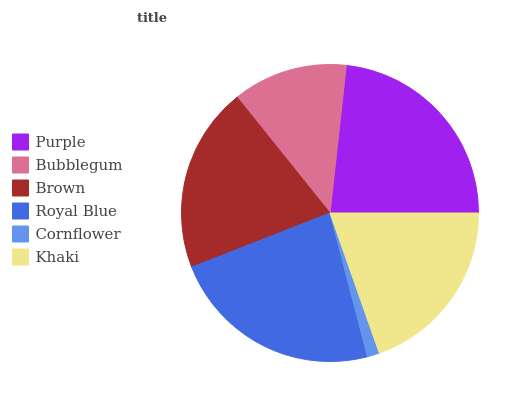Is Cornflower the minimum?
Answer yes or no. Yes. Is Purple the maximum?
Answer yes or no. Yes. Is Bubblegum the minimum?
Answer yes or no. No. Is Bubblegum the maximum?
Answer yes or no. No. Is Purple greater than Bubblegum?
Answer yes or no. Yes. Is Bubblegum less than Purple?
Answer yes or no. Yes. Is Bubblegum greater than Purple?
Answer yes or no. No. Is Purple less than Bubblegum?
Answer yes or no. No. Is Brown the high median?
Answer yes or no. Yes. Is Khaki the low median?
Answer yes or no. Yes. Is Bubblegum the high median?
Answer yes or no. No. Is Brown the low median?
Answer yes or no. No. 